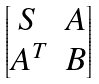<formula> <loc_0><loc_0><loc_500><loc_500>\begin{bmatrix} S & A \\ A ^ { T } & B \end{bmatrix}</formula> 